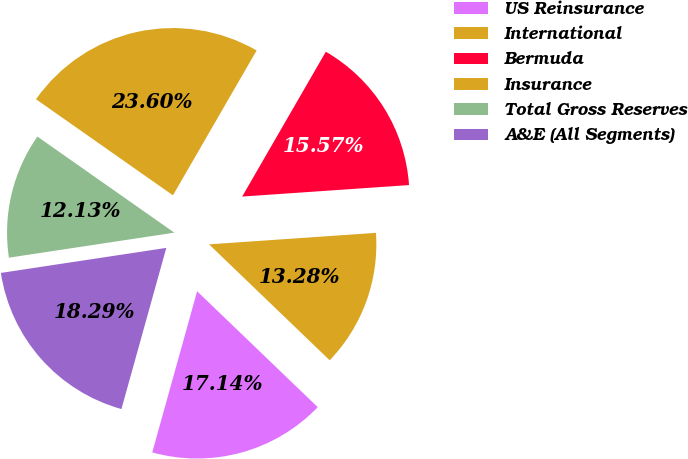Convert chart. <chart><loc_0><loc_0><loc_500><loc_500><pie_chart><fcel>US Reinsurance<fcel>International<fcel>Bermuda<fcel>Insurance<fcel>Total Gross Reserves<fcel>A&E (All Segments)<nl><fcel>17.14%<fcel>13.28%<fcel>15.57%<fcel>23.6%<fcel>12.13%<fcel>18.29%<nl></chart> 